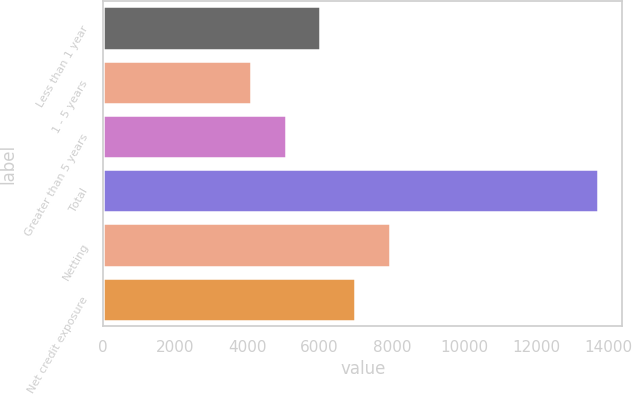Convert chart to OTSL. <chart><loc_0><loc_0><loc_500><loc_500><bar_chart><fcel>Less than 1 year<fcel>1 - 5 years<fcel>Greater than 5 years<fcel>Total<fcel>Netting<fcel>Net credit exposure<nl><fcel>6014.6<fcel>4091<fcel>5052.8<fcel>13709<fcel>7938.2<fcel>6976.4<nl></chart> 